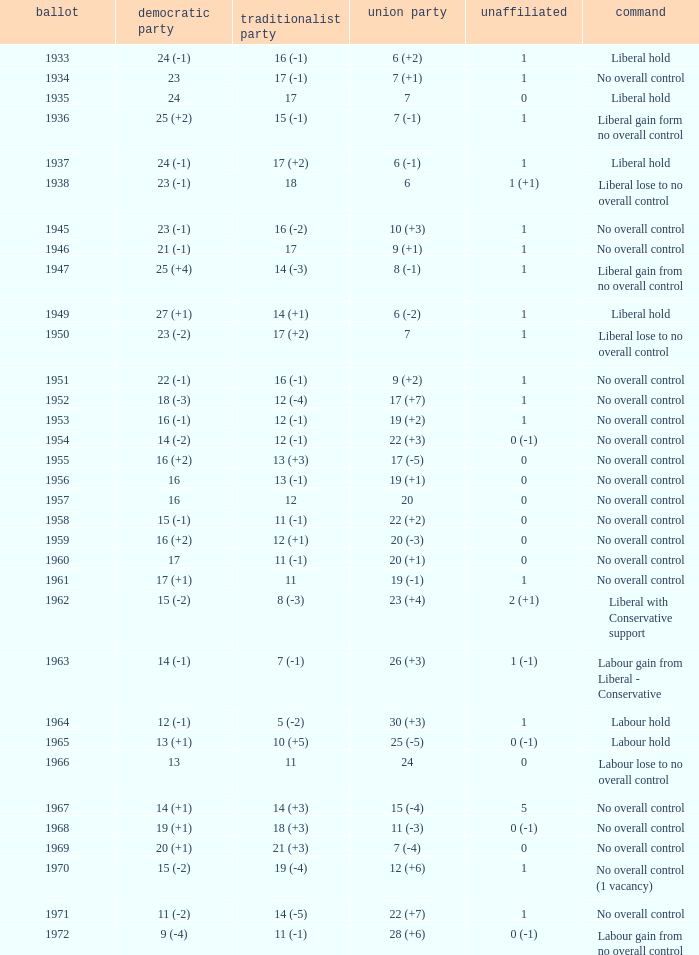What was the Liberal Party result from the election having a Conservative Party result of 16 (-1) and Labour of 6 (+2)? 24 (-1). 